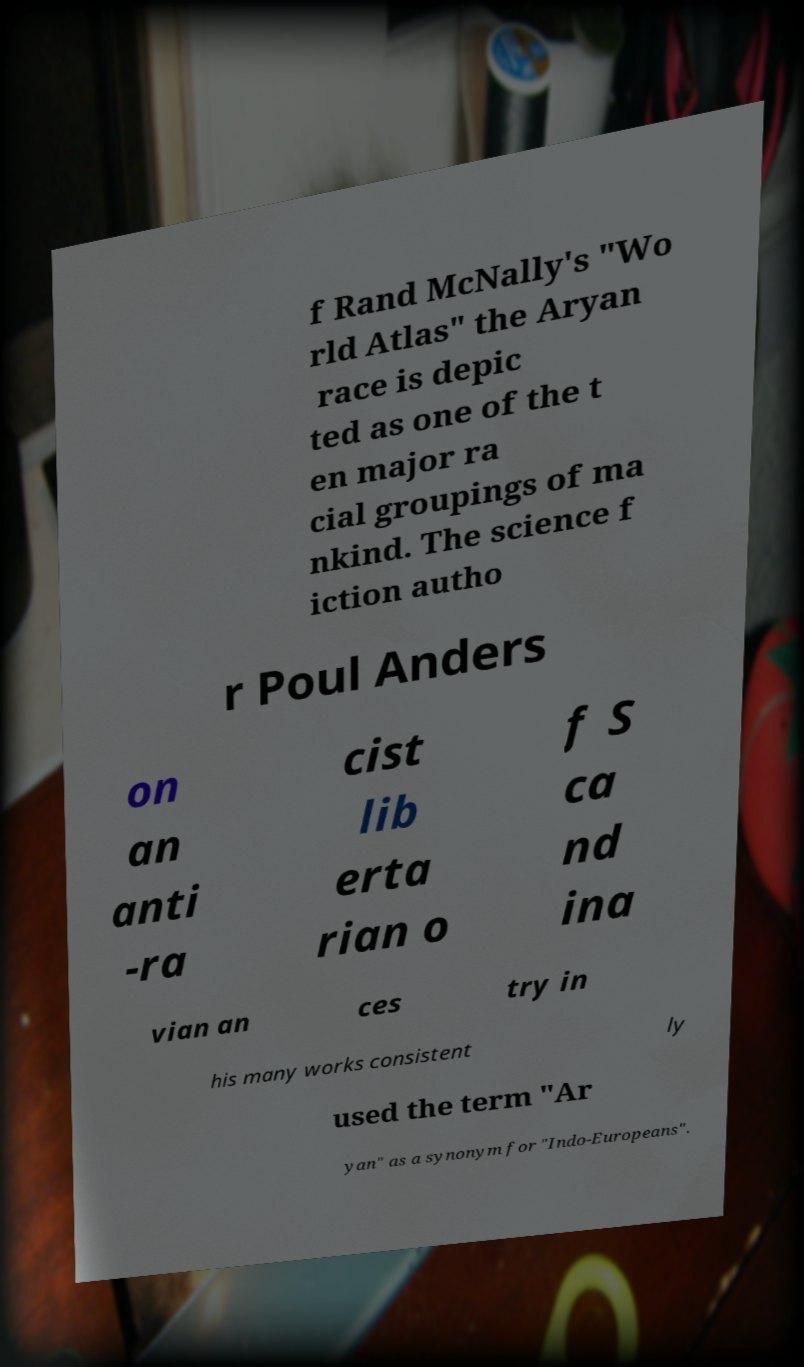There's text embedded in this image that I need extracted. Can you transcribe it verbatim? f Rand McNally's "Wo rld Atlas" the Aryan race is depic ted as one of the t en major ra cial groupings of ma nkind. The science f iction autho r Poul Anders on an anti -ra cist lib erta rian o f S ca nd ina vian an ces try in his many works consistent ly used the term "Ar yan" as a synonym for "Indo-Europeans". 